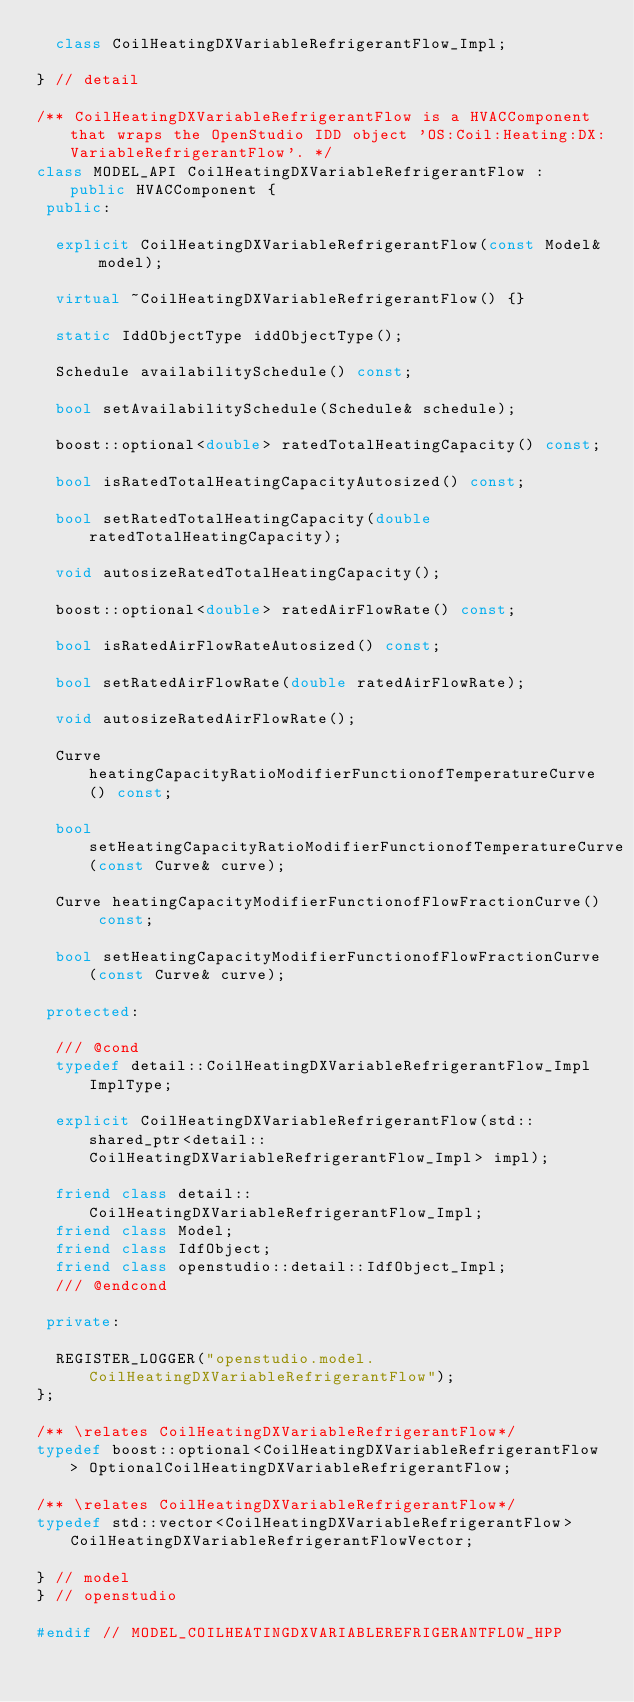Convert code to text. <code><loc_0><loc_0><loc_500><loc_500><_C++_>  class CoilHeatingDXVariableRefrigerantFlow_Impl;

} // detail

/** CoilHeatingDXVariableRefrigerantFlow is a HVACComponent that wraps the OpenStudio IDD object 'OS:Coil:Heating:DX:VariableRefrigerantFlow'. */
class MODEL_API CoilHeatingDXVariableRefrigerantFlow : public HVACComponent {
 public:

  explicit CoilHeatingDXVariableRefrigerantFlow(const Model& model);

  virtual ~CoilHeatingDXVariableRefrigerantFlow() {}

  static IddObjectType iddObjectType();

  Schedule availabilitySchedule() const;

  bool setAvailabilitySchedule(Schedule& schedule);

  boost::optional<double> ratedTotalHeatingCapacity() const;

  bool isRatedTotalHeatingCapacityAutosized() const;

  bool setRatedTotalHeatingCapacity(double ratedTotalHeatingCapacity);

  void autosizeRatedTotalHeatingCapacity();

  boost::optional<double> ratedAirFlowRate() const;

  bool isRatedAirFlowRateAutosized() const;

  bool setRatedAirFlowRate(double ratedAirFlowRate);

  void autosizeRatedAirFlowRate();

  Curve heatingCapacityRatioModifierFunctionofTemperatureCurve() const;

  bool setHeatingCapacityRatioModifierFunctionofTemperatureCurve(const Curve& curve);

  Curve heatingCapacityModifierFunctionofFlowFractionCurve() const;

  bool setHeatingCapacityModifierFunctionofFlowFractionCurve(const Curve& curve);

 protected:

  /// @cond
  typedef detail::CoilHeatingDXVariableRefrigerantFlow_Impl ImplType;

  explicit CoilHeatingDXVariableRefrigerantFlow(std::shared_ptr<detail::CoilHeatingDXVariableRefrigerantFlow_Impl> impl);

  friend class detail::CoilHeatingDXVariableRefrigerantFlow_Impl;
  friend class Model;
  friend class IdfObject;
  friend class openstudio::detail::IdfObject_Impl;
  /// @endcond

 private:

  REGISTER_LOGGER("openstudio.model.CoilHeatingDXVariableRefrigerantFlow");
};

/** \relates CoilHeatingDXVariableRefrigerantFlow*/
typedef boost::optional<CoilHeatingDXVariableRefrigerantFlow> OptionalCoilHeatingDXVariableRefrigerantFlow;

/** \relates CoilHeatingDXVariableRefrigerantFlow*/
typedef std::vector<CoilHeatingDXVariableRefrigerantFlow> CoilHeatingDXVariableRefrigerantFlowVector;

} // model
} // openstudio

#endif // MODEL_COILHEATINGDXVARIABLEREFRIGERANTFLOW_HPP

</code> 